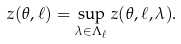<formula> <loc_0><loc_0><loc_500><loc_500>z ( \theta , \ell ) = \sup _ { \lambda \in \Lambda _ { \ell } } z ( \theta , \ell , \lambda ) .</formula> 